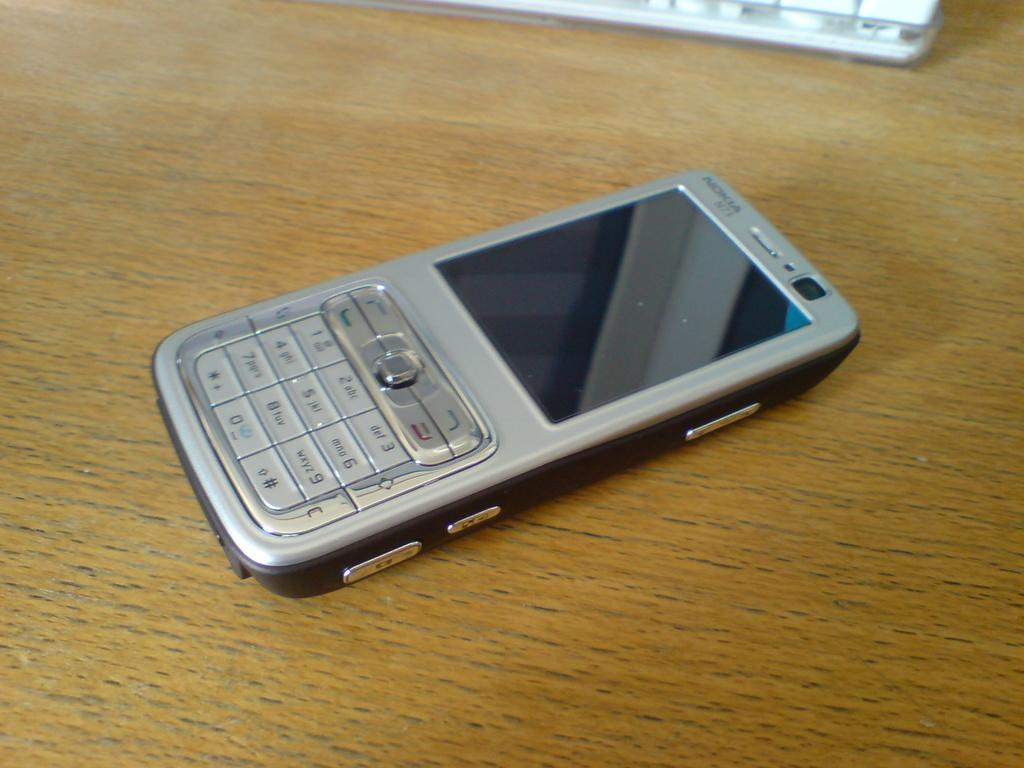<image>
Provide a brief description of the given image. A Nokia cell phone is laying on a table. 